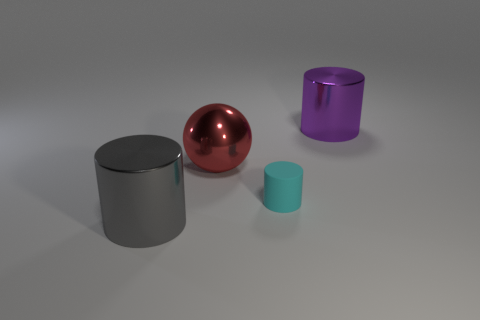Add 3 large purple objects. How many objects exist? 7 Subtract all cylinders. How many objects are left? 1 Subtract 0 purple cubes. How many objects are left? 4 Subtract all large red objects. Subtract all large yellow cubes. How many objects are left? 3 Add 4 red balls. How many red balls are left? 5 Add 4 tiny spheres. How many tiny spheres exist? 4 